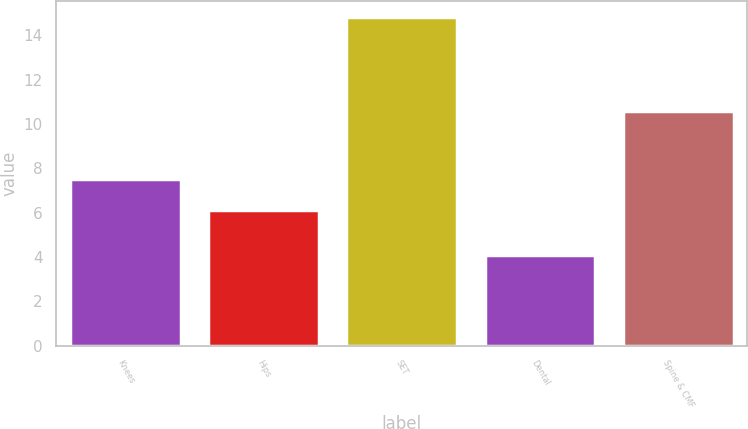Convert chart to OTSL. <chart><loc_0><loc_0><loc_500><loc_500><bar_chart><fcel>Knees<fcel>Hips<fcel>SET<fcel>Dental<fcel>Spine & CMF<nl><fcel>7.5<fcel>6.1<fcel>14.8<fcel>4.1<fcel>10.6<nl></chart> 